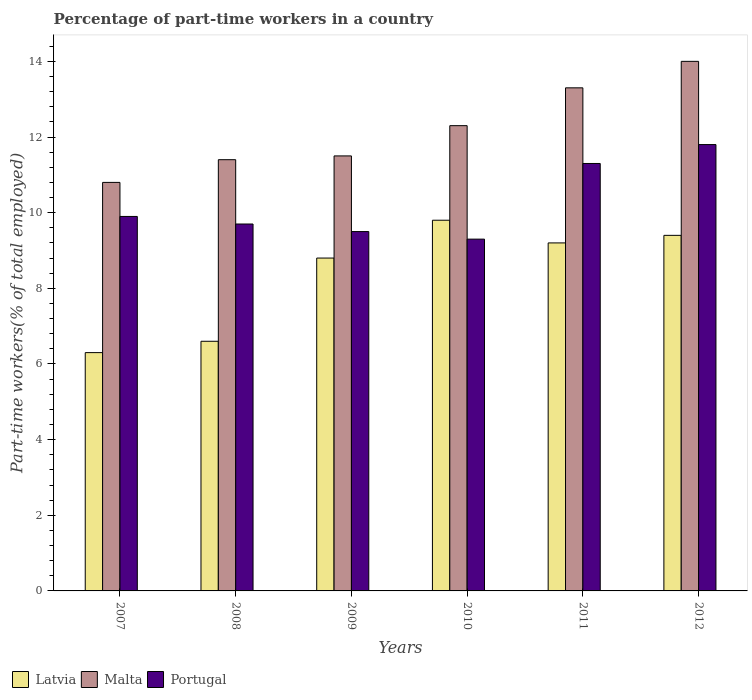Are the number of bars per tick equal to the number of legend labels?
Keep it short and to the point. Yes. How many bars are there on the 2nd tick from the right?
Provide a short and direct response. 3. What is the percentage of part-time workers in Latvia in 2011?
Provide a short and direct response. 9.2. Across all years, what is the maximum percentage of part-time workers in Portugal?
Ensure brevity in your answer.  11.8. Across all years, what is the minimum percentage of part-time workers in Latvia?
Give a very brief answer. 6.3. What is the total percentage of part-time workers in Malta in the graph?
Make the answer very short. 73.3. What is the difference between the percentage of part-time workers in Portugal in 2007 and that in 2012?
Make the answer very short. -1.9. What is the difference between the percentage of part-time workers in Latvia in 2009 and the percentage of part-time workers in Portugal in 2012?
Offer a very short reply. -3. What is the average percentage of part-time workers in Latvia per year?
Your answer should be very brief. 8.35. In the year 2009, what is the difference between the percentage of part-time workers in Malta and percentage of part-time workers in Portugal?
Offer a very short reply. 2. What is the ratio of the percentage of part-time workers in Latvia in 2008 to that in 2009?
Offer a terse response. 0.75. What is the difference between the highest and the lowest percentage of part-time workers in Latvia?
Your response must be concise. 3.5. Is the sum of the percentage of part-time workers in Portugal in 2008 and 2010 greater than the maximum percentage of part-time workers in Latvia across all years?
Provide a succinct answer. Yes. What does the 1st bar from the left in 2007 represents?
Keep it short and to the point. Latvia. What does the 3rd bar from the right in 2007 represents?
Make the answer very short. Latvia. Is it the case that in every year, the sum of the percentage of part-time workers in Portugal and percentage of part-time workers in Latvia is greater than the percentage of part-time workers in Malta?
Provide a short and direct response. Yes. How many bars are there?
Provide a succinct answer. 18. Are all the bars in the graph horizontal?
Offer a very short reply. No. Are the values on the major ticks of Y-axis written in scientific E-notation?
Keep it short and to the point. No. Does the graph contain any zero values?
Ensure brevity in your answer.  No. Does the graph contain grids?
Your answer should be very brief. No. Where does the legend appear in the graph?
Provide a short and direct response. Bottom left. How are the legend labels stacked?
Keep it short and to the point. Horizontal. What is the title of the graph?
Your response must be concise. Percentage of part-time workers in a country. What is the label or title of the X-axis?
Your answer should be very brief. Years. What is the label or title of the Y-axis?
Your answer should be compact. Part-time workers(% of total employed). What is the Part-time workers(% of total employed) of Latvia in 2007?
Your answer should be very brief. 6.3. What is the Part-time workers(% of total employed) of Malta in 2007?
Give a very brief answer. 10.8. What is the Part-time workers(% of total employed) in Portugal in 2007?
Your answer should be compact. 9.9. What is the Part-time workers(% of total employed) of Latvia in 2008?
Offer a terse response. 6.6. What is the Part-time workers(% of total employed) of Malta in 2008?
Offer a terse response. 11.4. What is the Part-time workers(% of total employed) of Portugal in 2008?
Your response must be concise. 9.7. What is the Part-time workers(% of total employed) of Latvia in 2009?
Give a very brief answer. 8.8. What is the Part-time workers(% of total employed) in Portugal in 2009?
Offer a very short reply. 9.5. What is the Part-time workers(% of total employed) in Latvia in 2010?
Your answer should be compact. 9.8. What is the Part-time workers(% of total employed) of Malta in 2010?
Your answer should be very brief. 12.3. What is the Part-time workers(% of total employed) of Portugal in 2010?
Provide a short and direct response. 9.3. What is the Part-time workers(% of total employed) of Latvia in 2011?
Provide a short and direct response. 9.2. What is the Part-time workers(% of total employed) in Malta in 2011?
Keep it short and to the point. 13.3. What is the Part-time workers(% of total employed) of Portugal in 2011?
Give a very brief answer. 11.3. What is the Part-time workers(% of total employed) in Latvia in 2012?
Provide a short and direct response. 9.4. What is the Part-time workers(% of total employed) in Portugal in 2012?
Your response must be concise. 11.8. Across all years, what is the maximum Part-time workers(% of total employed) in Latvia?
Your answer should be compact. 9.8. Across all years, what is the maximum Part-time workers(% of total employed) of Portugal?
Provide a succinct answer. 11.8. Across all years, what is the minimum Part-time workers(% of total employed) in Latvia?
Your answer should be very brief. 6.3. Across all years, what is the minimum Part-time workers(% of total employed) of Malta?
Ensure brevity in your answer.  10.8. Across all years, what is the minimum Part-time workers(% of total employed) of Portugal?
Provide a succinct answer. 9.3. What is the total Part-time workers(% of total employed) of Latvia in the graph?
Provide a succinct answer. 50.1. What is the total Part-time workers(% of total employed) in Malta in the graph?
Offer a very short reply. 73.3. What is the total Part-time workers(% of total employed) of Portugal in the graph?
Your answer should be compact. 61.5. What is the difference between the Part-time workers(% of total employed) of Portugal in 2007 and that in 2008?
Provide a short and direct response. 0.2. What is the difference between the Part-time workers(% of total employed) of Latvia in 2007 and that in 2009?
Offer a very short reply. -2.5. What is the difference between the Part-time workers(% of total employed) of Portugal in 2007 and that in 2009?
Make the answer very short. 0.4. What is the difference between the Part-time workers(% of total employed) in Latvia in 2007 and that in 2010?
Your answer should be very brief. -3.5. What is the difference between the Part-time workers(% of total employed) in Malta in 2007 and that in 2011?
Your answer should be compact. -2.5. What is the difference between the Part-time workers(% of total employed) in Portugal in 2007 and that in 2011?
Offer a terse response. -1.4. What is the difference between the Part-time workers(% of total employed) in Malta in 2007 and that in 2012?
Offer a very short reply. -3.2. What is the difference between the Part-time workers(% of total employed) of Malta in 2008 and that in 2011?
Your answer should be very brief. -1.9. What is the difference between the Part-time workers(% of total employed) in Portugal in 2008 and that in 2011?
Your response must be concise. -1.6. What is the difference between the Part-time workers(% of total employed) in Latvia in 2008 and that in 2012?
Provide a short and direct response. -2.8. What is the difference between the Part-time workers(% of total employed) of Portugal in 2008 and that in 2012?
Your answer should be very brief. -2.1. What is the difference between the Part-time workers(% of total employed) of Latvia in 2009 and that in 2010?
Your response must be concise. -1. What is the difference between the Part-time workers(% of total employed) in Portugal in 2009 and that in 2010?
Offer a very short reply. 0.2. What is the difference between the Part-time workers(% of total employed) in Latvia in 2009 and that in 2011?
Offer a very short reply. -0.4. What is the difference between the Part-time workers(% of total employed) of Portugal in 2009 and that in 2011?
Your answer should be compact. -1.8. What is the difference between the Part-time workers(% of total employed) in Latvia in 2009 and that in 2012?
Offer a terse response. -0.6. What is the difference between the Part-time workers(% of total employed) in Portugal in 2009 and that in 2012?
Your response must be concise. -2.3. What is the difference between the Part-time workers(% of total employed) of Malta in 2010 and that in 2011?
Ensure brevity in your answer.  -1. What is the difference between the Part-time workers(% of total employed) of Portugal in 2010 and that in 2011?
Your answer should be very brief. -2. What is the difference between the Part-time workers(% of total employed) of Latvia in 2010 and that in 2012?
Your response must be concise. 0.4. What is the difference between the Part-time workers(% of total employed) of Malta in 2010 and that in 2012?
Offer a terse response. -1.7. What is the difference between the Part-time workers(% of total employed) in Portugal in 2010 and that in 2012?
Provide a succinct answer. -2.5. What is the difference between the Part-time workers(% of total employed) in Latvia in 2011 and that in 2012?
Provide a succinct answer. -0.2. What is the difference between the Part-time workers(% of total employed) of Latvia in 2007 and the Part-time workers(% of total employed) of Portugal in 2008?
Keep it short and to the point. -3.4. What is the difference between the Part-time workers(% of total employed) of Latvia in 2007 and the Part-time workers(% of total employed) of Malta in 2009?
Make the answer very short. -5.2. What is the difference between the Part-time workers(% of total employed) in Latvia in 2007 and the Part-time workers(% of total employed) in Malta in 2011?
Provide a short and direct response. -7. What is the difference between the Part-time workers(% of total employed) in Latvia in 2007 and the Part-time workers(% of total employed) in Portugal in 2011?
Your answer should be compact. -5. What is the difference between the Part-time workers(% of total employed) in Malta in 2007 and the Part-time workers(% of total employed) in Portugal in 2011?
Provide a succinct answer. -0.5. What is the difference between the Part-time workers(% of total employed) of Latvia in 2007 and the Part-time workers(% of total employed) of Malta in 2012?
Offer a very short reply. -7.7. What is the difference between the Part-time workers(% of total employed) of Latvia in 2007 and the Part-time workers(% of total employed) of Portugal in 2012?
Give a very brief answer. -5.5. What is the difference between the Part-time workers(% of total employed) in Malta in 2008 and the Part-time workers(% of total employed) in Portugal in 2010?
Your response must be concise. 2.1. What is the difference between the Part-time workers(% of total employed) of Latvia in 2008 and the Part-time workers(% of total employed) of Malta in 2011?
Your response must be concise. -6.7. What is the difference between the Part-time workers(% of total employed) in Latvia in 2008 and the Part-time workers(% of total employed) in Portugal in 2011?
Your answer should be very brief. -4.7. What is the difference between the Part-time workers(% of total employed) in Latvia in 2008 and the Part-time workers(% of total employed) in Portugal in 2012?
Provide a succinct answer. -5.2. What is the difference between the Part-time workers(% of total employed) in Latvia in 2009 and the Part-time workers(% of total employed) in Malta in 2010?
Offer a terse response. -3.5. What is the difference between the Part-time workers(% of total employed) in Malta in 2009 and the Part-time workers(% of total employed) in Portugal in 2010?
Your response must be concise. 2.2. What is the difference between the Part-time workers(% of total employed) in Latvia in 2009 and the Part-time workers(% of total employed) in Portugal in 2011?
Your answer should be compact. -2.5. What is the difference between the Part-time workers(% of total employed) in Malta in 2009 and the Part-time workers(% of total employed) in Portugal in 2012?
Offer a terse response. -0.3. What is the difference between the Part-time workers(% of total employed) in Latvia in 2010 and the Part-time workers(% of total employed) in Malta in 2011?
Keep it short and to the point. -3.5. What is the difference between the Part-time workers(% of total employed) of Malta in 2010 and the Part-time workers(% of total employed) of Portugal in 2011?
Ensure brevity in your answer.  1. What is the difference between the Part-time workers(% of total employed) in Latvia in 2010 and the Part-time workers(% of total employed) in Malta in 2012?
Your answer should be very brief. -4.2. What is the difference between the Part-time workers(% of total employed) of Latvia in 2011 and the Part-time workers(% of total employed) of Malta in 2012?
Provide a succinct answer. -4.8. What is the difference between the Part-time workers(% of total employed) in Latvia in 2011 and the Part-time workers(% of total employed) in Portugal in 2012?
Give a very brief answer. -2.6. What is the difference between the Part-time workers(% of total employed) in Malta in 2011 and the Part-time workers(% of total employed) in Portugal in 2012?
Give a very brief answer. 1.5. What is the average Part-time workers(% of total employed) in Latvia per year?
Keep it short and to the point. 8.35. What is the average Part-time workers(% of total employed) in Malta per year?
Make the answer very short. 12.22. What is the average Part-time workers(% of total employed) of Portugal per year?
Provide a succinct answer. 10.25. In the year 2007, what is the difference between the Part-time workers(% of total employed) of Latvia and Part-time workers(% of total employed) of Portugal?
Provide a succinct answer. -3.6. In the year 2007, what is the difference between the Part-time workers(% of total employed) of Malta and Part-time workers(% of total employed) of Portugal?
Ensure brevity in your answer.  0.9. In the year 2008, what is the difference between the Part-time workers(% of total employed) of Latvia and Part-time workers(% of total employed) of Portugal?
Keep it short and to the point. -3.1. In the year 2009, what is the difference between the Part-time workers(% of total employed) of Malta and Part-time workers(% of total employed) of Portugal?
Ensure brevity in your answer.  2. In the year 2010, what is the difference between the Part-time workers(% of total employed) in Latvia and Part-time workers(% of total employed) in Malta?
Give a very brief answer. -2.5. In the year 2010, what is the difference between the Part-time workers(% of total employed) of Latvia and Part-time workers(% of total employed) of Portugal?
Provide a succinct answer. 0.5. In the year 2011, what is the difference between the Part-time workers(% of total employed) in Latvia and Part-time workers(% of total employed) in Malta?
Your answer should be compact. -4.1. In the year 2012, what is the difference between the Part-time workers(% of total employed) of Latvia and Part-time workers(% of total employed) of Malta?
Your response must be concise. -4.6. In the year 2012, what is the difference between the Part-time workers(% of total employed) in Malta and Part-time workers(% of total employed) in Portugal?
Keep it short and to the point. 2.2. What is the ratio of the Part-time workers(% of total employed) in Latvia in 2007 to that in 2008?
Provide a short and direct response. 0.95. What is the ratio of the Part-time workers(% of total employed) in Portugal in 2007 to that in 2008?
Make the answer very short. 1.02. What is the ratio of the Part-time workers(% of total employed) in Latvia in 2007 to that in 2009?
Your response must be concise. 0.72. What is the ratio of the Part-time workers(% of total employed) of Malta in 2007 to that in 2009?
Ensure brevity in your answer.  0.94. What is the ratio of the Part-time workers(% of total employed) of Portugal in 2007 to that in 2009?
Offer a terse response. 1.04. What is the ratio of the Part-time workers(% of total employed) of Latvia in 2007 to that in 2010?
Offer a terse response. 0.64. What is the ratio of the Part-time workers(% of total employed) in Malta in 2007 to that in 2010?
Provide a succinct answer. 0.88. What is the ratio of the Part-time workers(% of total employed) in Portugal in 2007 to that in 2010?
Offer a terse response. 1.06. What is the ratio of the Part-time workers(% of total employed) of Latvia in 2007 to that in 2011?
Your response must be concise. 0.68. What is the ratio of the Part-time workers(% of total employed) of Malta in 2007 to that in 2011?
Make the answer very short. 0.81. What is the ratio of the Part-time workers(% of total employed) in Portugal in 2007 to that in 2011?
Keep it short and to the point. 0.88. What is the ratio of the Part-time workers(% of total employed) in Latvia in 2007 to that in 2012?
Provide a short and direct response. 0.67. What is the ratio of the Part-time workers(% of total employed) in Malta in 2007 to that in 2012?
Give a very brief answer. 0.77. What is the ratio of the Part-time workers(% of total employed) in Portugal in 2007 to that in 2012?
Your response must be concise. 0.84. What is the ratio of the Part-time workers(% of total employed) in Latvia in 2008 to that in 2009?
Your response must be concise. 0.75. What is the ratio of the Part-time workers(% of total employed) of Malta in 2008 to that in 2009?
Ensure brevity in your answer.  0.99. What is the ratio of the Part-time workers(% of total employed) in Portugal in 2008 to that in 2009?
Offer a terse response. 1.02. What is the ratio of the Part-time workers(% of total employed) of Latvia in 2008 to that in 2010?
Offer a very short reply. 0.67. What is the ratio of the Part-time workers(% of total employed) in Malta in 2008 to that in 2010?
Offer a terse response. 0.93. What is the ratio of the Part-time workers(% of total employed) in Portugal in 2008 to that in 2010?
Your answer should be very brief. 1.04. What is the ratio of the Part-time workers(% of total employed) in Latvia in 2008 to that in 2011?
Your response must be concise. 0.72. What is the ratio of the Part-time workers(% of total employed) in Malta in 2008 to that in 2011?
Offer a very short reply. 0.86. What is the ratio of the Part-time workers(% of total employed) of Portugal in 2008 to that in 2011?
Your response must be concise. 0.86. What is the ratio of the Part-time workers(% of total employed) of Latvia in 2008 to that in 2012?
Give a very brief answer. 0.7. What is the ratio of the Part-time workers(% of total employed) in Malta in 2008 to that in 2012?
Keep it short and to the point. 0.81. What is the ratio of the Part-time workers(% of total employed) in Portugal in 2008 to that in 2012?
Offer a terse response. 0.82. What is the ratio of the Part-time workers(% of total employed) in Latvia in 2009 to that in 2010?
Keep it short and to the point. 0.9. What is the ratio of the Part-time workers(% of total employed) in Malta in 2009 to that in 2010?
Your answer should be very brief. 0.94. What is the ratio of the Part-time workers(% of total employed) of Portugal in 2009 to that in 2010?
Give a very brief answer. 1.02. What is the ratio of the Part-time workers(% of total employed) in Latvia in 2009 to that in 2011?
Give a very brief answer. 0.96. What is the ratio of the Part-time workers(% of total employed) of Malta in 2009 to that in 2011?
Your answer should be compact. 0.86. What is the ratio of the Part-time workers(% of total employed) of Portugal in 2009 to that in 2011?
Make the answer very short. 0.84. What is the ratio of the Part-time workers(% of total employed) in Latvia in 2009 to that in 2012?
Keep it short and to the point. 0.94. What is the ratio of the Part-time workers(% of total employed) in Malta in 2009 to that in 2012?
Provide a succinct answer. 0.82. What is the ratio of the Part-time workers(% of total employed) in Portugal in 2009 to that in 2012?
Ensure brevity in your answer.  0.81. What is the ratio of the Part-time workers(% of total employed) of Latvia in 2010 to that in 2011?
Keep it short and to the point. 1.07. What is the ratio of the Part-time workers(% of total employed) of Malta in 2010 to that in 2011?
Your answer should be compact. 0.92. What is the ratio of the Part-time workers(% of total employed) of Portugal in 2010 to that in 2011?
Your answer should be compact. 0.82. What is the ratio of the Part-time workers(% of total employed) in Latvia in 2010 to that in 2012?
Offer a very short reply. 1.04. What is the ratio of the Part-time workers(% of total employed) of Malta in 2010 to that in 2012?
Provide a short and direct response. 0.88. What is the ratio of the Part-time workers(% of total employed) of Portugal in 2010 to that in 2012?
Offer a very short reply. 0.79. What is the ratio of the Part-time workers(% of total employed) of Latvia in 2011 to that in 2012?
Your answer should be compact. 0.98. What is the ratio of the Part-time workers(% of total employed) of Malta in 2011 to that in 2012?
Offer a terse response. 0.95. What is the ratio of the Part-time workers(% of total employed) of Portugal in 2011 to that in 2012?
Provide a short and direct response. 0.96. What is the difference between the highest and the second highest Part-time workers(% of total employed) of Latvia?
Make the answer very short. 0.4. What is the difference between the highest and the lowest Part-time workers(% of total employed) in Latvia?
Provide a short and direct response. 3.5. What is the difference between the highest and the lowest Part-time workers(% of total employed) in Malta?
Provide a succinct answer. 3.2. 